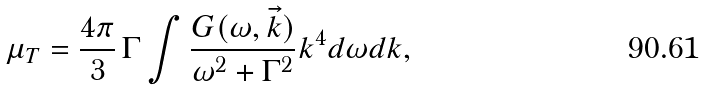<formula> <loc_0><loc_0><loc_500><loc_500>\mu _ { T } = \frac { 4 \pi } { 3 } \, \Gamma \int \frac { G ( \omega , \vec { k } ) } { \omega ^ { 2 } + \Gamma ^ { 2 } } k ^ { 4 } d \omega d k ,</formula> 